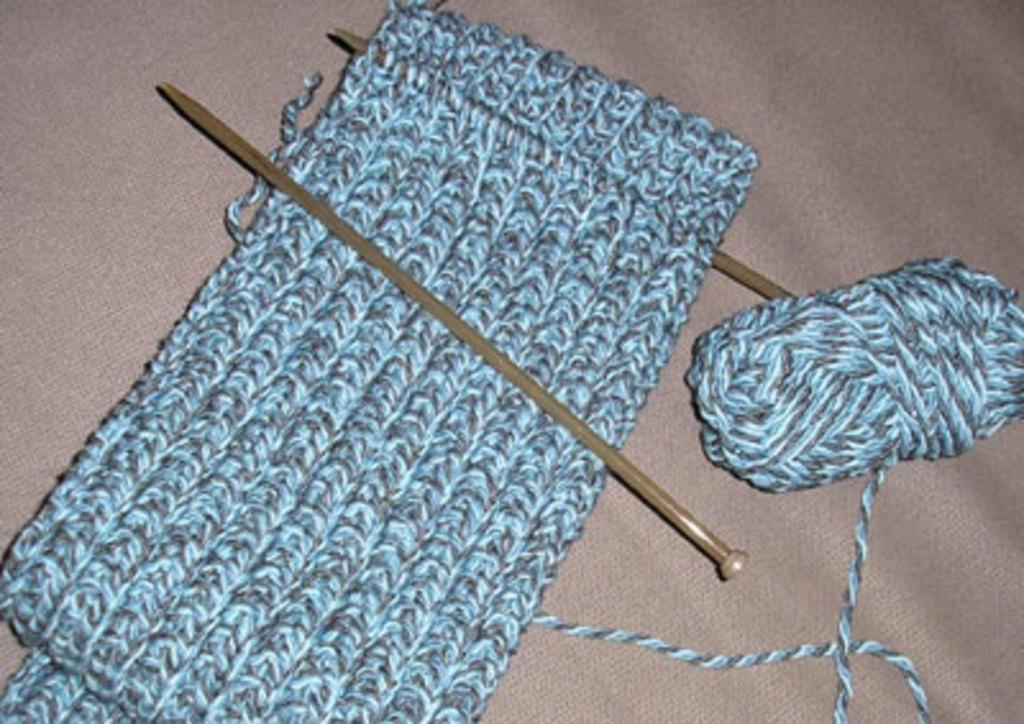What type of material is present in the image? There is a woolen thread in the image. What tools are used with the woolen thread? There are two needles in the image. What is the woolen thread used for in the image? There is a cloth prepared with the woolen thread in the image. Where is the drawer located in the image? There is no drawer present in the image. What type of gardening tool is used in the image? There is no gardening tool, such as a rake, present in the image. 